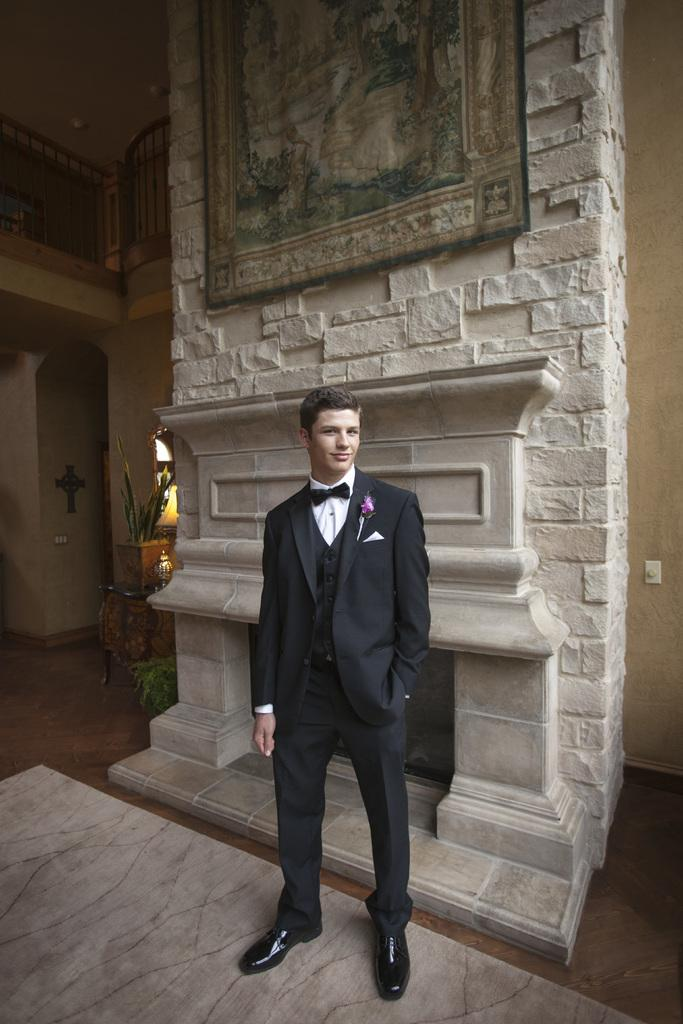Who or what is present in the image? There is a person in the image. What is the person wearing? The person is wearing clothes. Where is the person standing in the image? The person is standing in front of a fireplace. What can be seen at the top of the image? There is an art piece at the top of the image. What type of quartz is being used as a drink in the image? There is no quartz or drink present in the image. What substance is the person holding in the image? The image does not show the person holding any substance. 